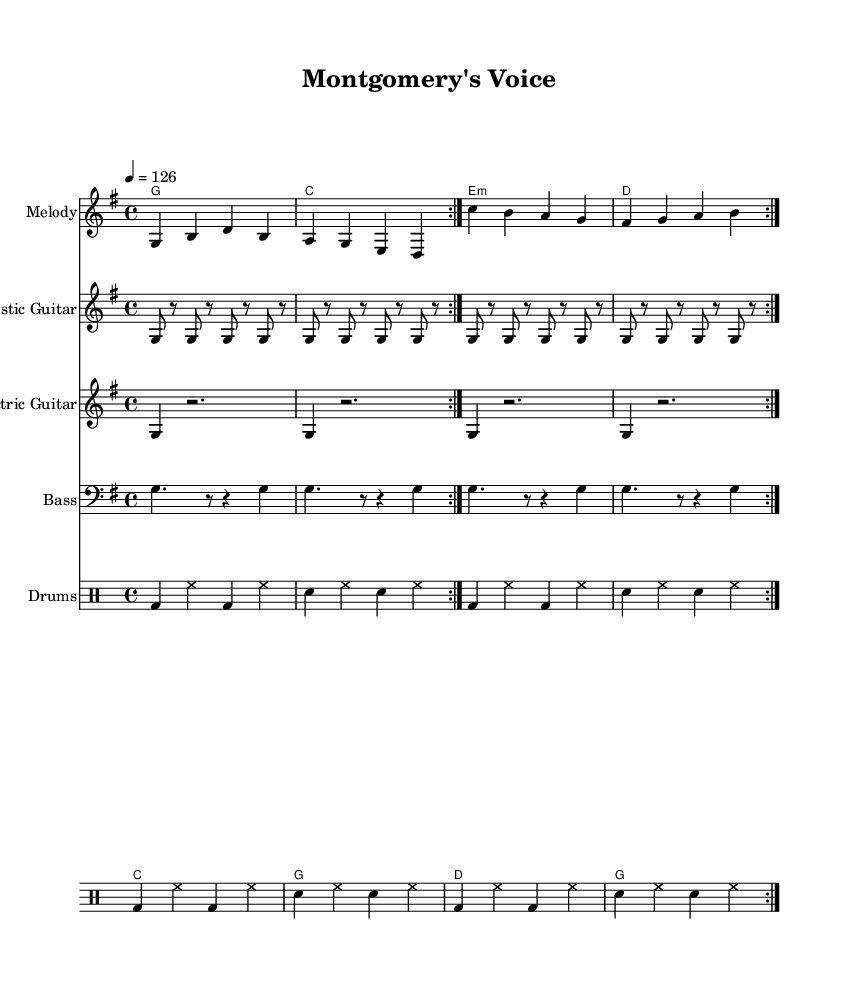What is the key signature of this music? The key signature is G major, which has one sharp (F#). This can be identified by looking at the key signature symbol at the beginning of the staff, right after the clef sign.
Answer: G major What is the time signature of the song? The time signature is 4/4, indicated at the beginning of the score. It shows that there are four beats in each measure and that the quarter note receives one beat.
Answer: 4/4 What is the tempo marking for this music? The tempo marking is 126 beats per minute, specified in the score using a numeric tempo indication. It indicates how fast the song should be played.
Answer: 126 How many verses are repeated? The score indicates that the verse is repeated twice, as shown by the "repeat volta" instruction before the verse in the score.
Answer: 2 What type of instruments are used in this piece? The piece features an acoustic guitar, electric guitar, bass, and drums, as indicated by instrument names on their respective staves in the score.
Answer: Acoustic Guitar, Electric Guitar, Bass, Drums What is the main theme of the lyrics? The lyrics focus on community engagement and belonging, as seen in the phrases such as "Montgomery County, this is our land," which convey a message of local pride and activism.
Answer: Community engagement How does the chorus relate to the verse thematically? The chorus, which encourages taking a stand and participating in the community, complements the verse, which describes connecting with the local environment and its people. This relationship enhances the song's overall message of active engagement in local politics.
Answer: Encouragement for community engagement 